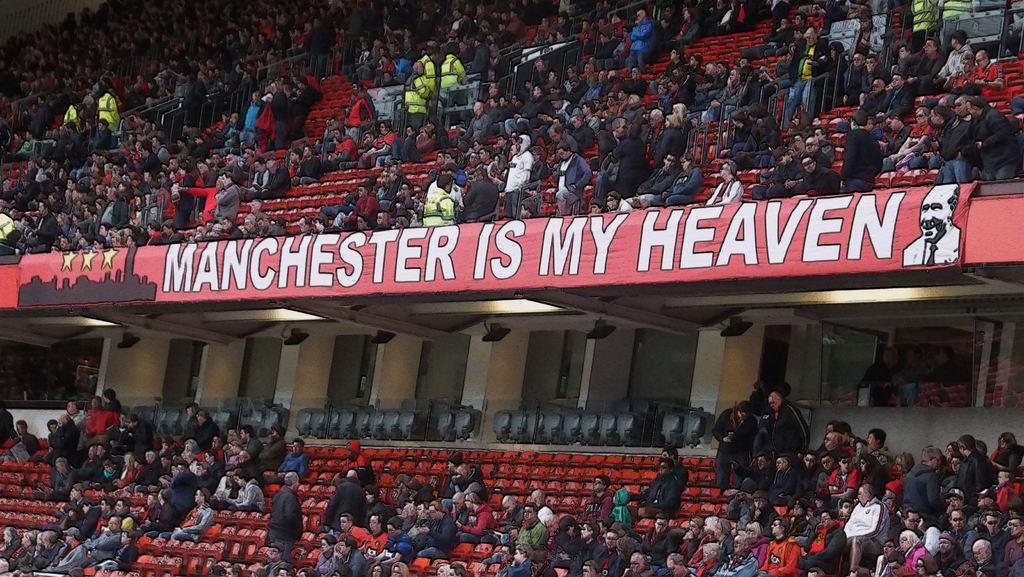In one or two sentences, can you explain what this image depicts? This is an edited image and this picture might be taken in a stadium, in this image in the center there are some boards. And at the top and bottom of the image there are group of people who are sitting, and some of them are standing and also there are some chairs, pillars, lights and some objects. 